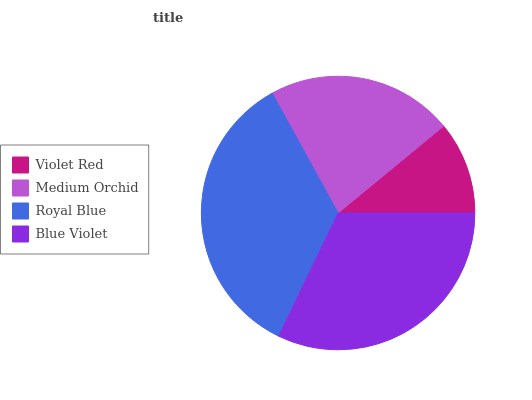Is Violet Red the minimum?
Answer yes or no. Yes. Is Royal Blue the maximum?
Answer yes or no. Yes. Is Medium Orchid the minimum?
Answer yes or no. No. Is Medium Orchid the maximum?
Answer yes or no. No. Is Medium Orchid greater than Violet Red?
Answer yes or no. Yes. Is Violet Red less than Medium Orchid?
Answer yes or no. Yes. Is Violet Red greater than Medium Orchid?
Answer yes or no. No. Is Medium Orchid less than Violet Red?
Answer yes or no. No. Is Blue Violet the high median?
Answer yes or no. Yes. Is Medium Orchid the low median?
Answer yes or no. Yes. Is Royal Blue the high median?
Answer yes or no. No. Is Violet Red the low median?
Answer yes or no. No. 